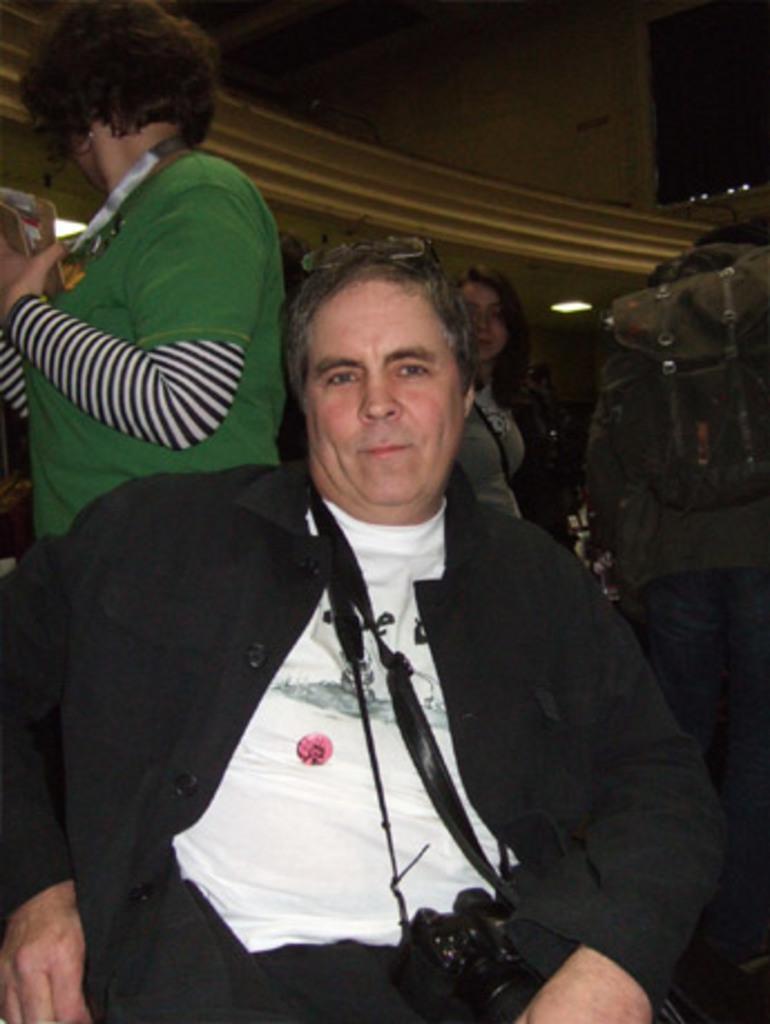Please provide a concise description of this image. In this picture there is a man sitting here and there are few people in the backdrop and there is a wall here. 